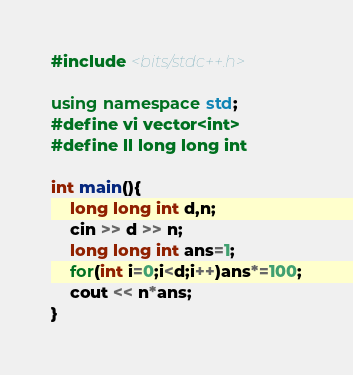Convert code to text. <code><loc_0><loc_0><loc_500><loc_500><_C++_>#include <bits/stdc++.h>

using namespace std;
#define vi vector<int>
#define ll long long int

int main(){
    long long int d,n;
    cin >> d >> n;
    long long int ans=1;
    for(int i=0;i<d;i++)ans*=100;
    cout << n*ans;
}</code> 